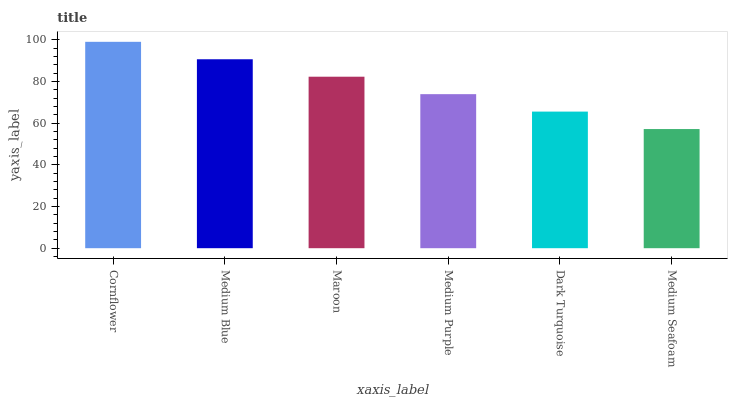Is Medium Blue the minimum?
Answer yes or no. No. Is Medium Blue the maximum?
Answer yes or no. No. Is Cornflower greater than Medium Blue?
Answer yes or no. Yes. Is Medium Blue less than Cornflower?
Answer yes or no. Yes. Is Medium Blue greater than Cornflower?
Answer yes or no. No. Is Cornflower less than Medium Blue?
Answer yes or no. No. Is Maroon the high median?
Answer yes or no. Yes. Is Medium Purple the low median?
Answer yes or no. Yes. Is Cornflower the high median?
Answer yes or no. No. Is Medium Seafoam the low median?
Answer yes or no. No. 